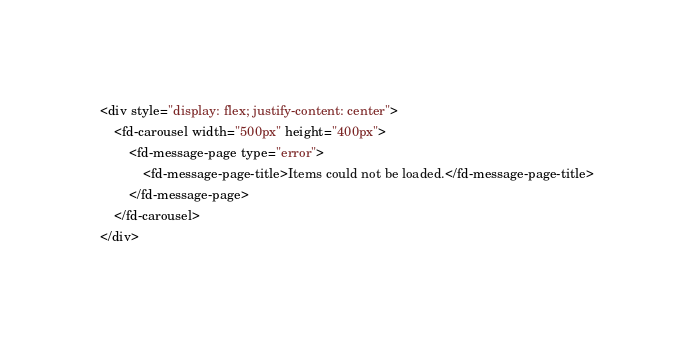Convert code to text. <code><loc_0><loc_0><loc_500><loc_500><_HTML_><div style="display: flex; justify-content: center">
    <fd-carousel width="500px" height="400px">
        <fd-message-page type="error">
            <fd-message-page-title>Items could not be loaded.</fd-message-page-title>
        </fd-message-page>
    </fd-carousel>
</div>
</code> 